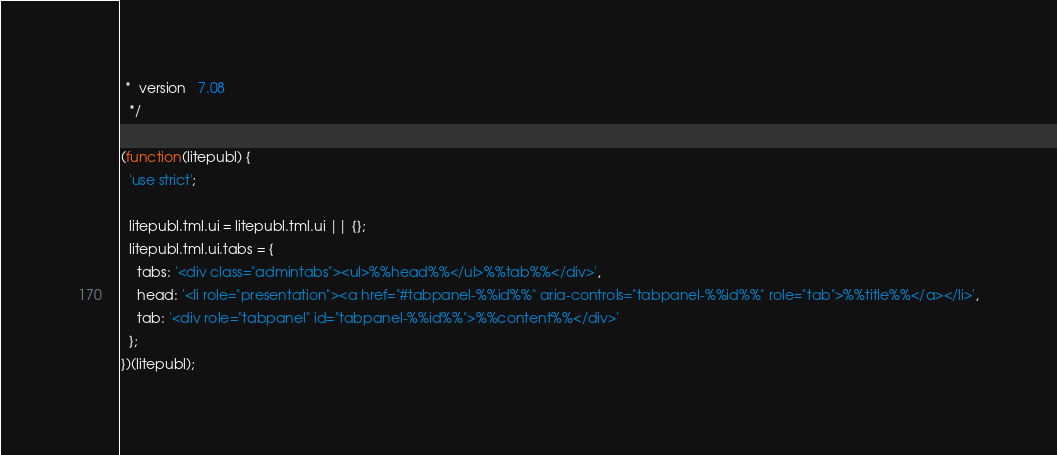<code> <loc_0><loc_0><loc_500><loc_500><_JavaScript_> *  version   7.08
  */

(function(litepubl) {
  'use strict';

  litepubl.tml.ui = litepubl.tml.ui || {};
  litepubl.tml.ui.tabs = {
    tabs: '<div class="admintabs"><ul>%%head%%</ul>%%tab%%</div>',
    head: '<li role="presentation"><a href="#tabpanel-%%id%%" aria-controls="tabpanel-%%id%%" role="tab">%%title%%</a></li>',
    tab: '<div role="tabpanel" id="tabpanel-%%id%%">%%content%%</div>'
  };
})(litepubl);</code> 